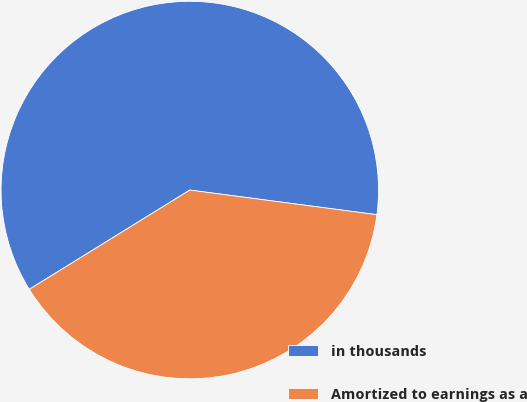Convert chart to OTSL. <chart><loc_0><loc_0><loc_500><loc_500><pie_chart><fcel>in thousands<fcel>Amortized to earnings as a<nl><fcel>60.9%<fcel>39.1%<nl></chart> 